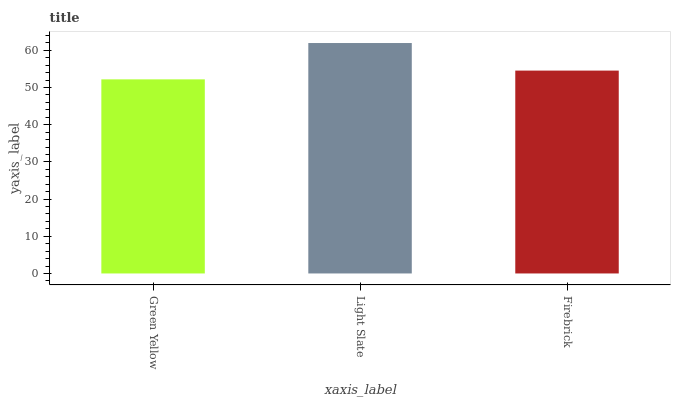Is Green Yellow the minimum?
Answer yes or no. Yes. Is Light Slate the maximum?
Answer yes or no. Yes. Is Firebrick the minimum?
Answer yes or no. No. Is Firebrick the maximum?
Answer yes or no. No. Is Light Slate greater than Firebrick?
Answer yes or no. Yes. Is Firebrick less than Light Slate?
Answer yes or no. Yes. Is Firebrick greater than Light Slate?
Answer yes or no. No. Is Light Slate less than Firebrick?
Answer yes or no. No. Is Firebrick the high median?
Answer yes or no. Yes. Is Firebrick the low median?
Answer yes or no. Yes. Is Light Slate the high median?
Answer yes or no. No. Is Light Slate the low median?
Answer yes or no. No. 